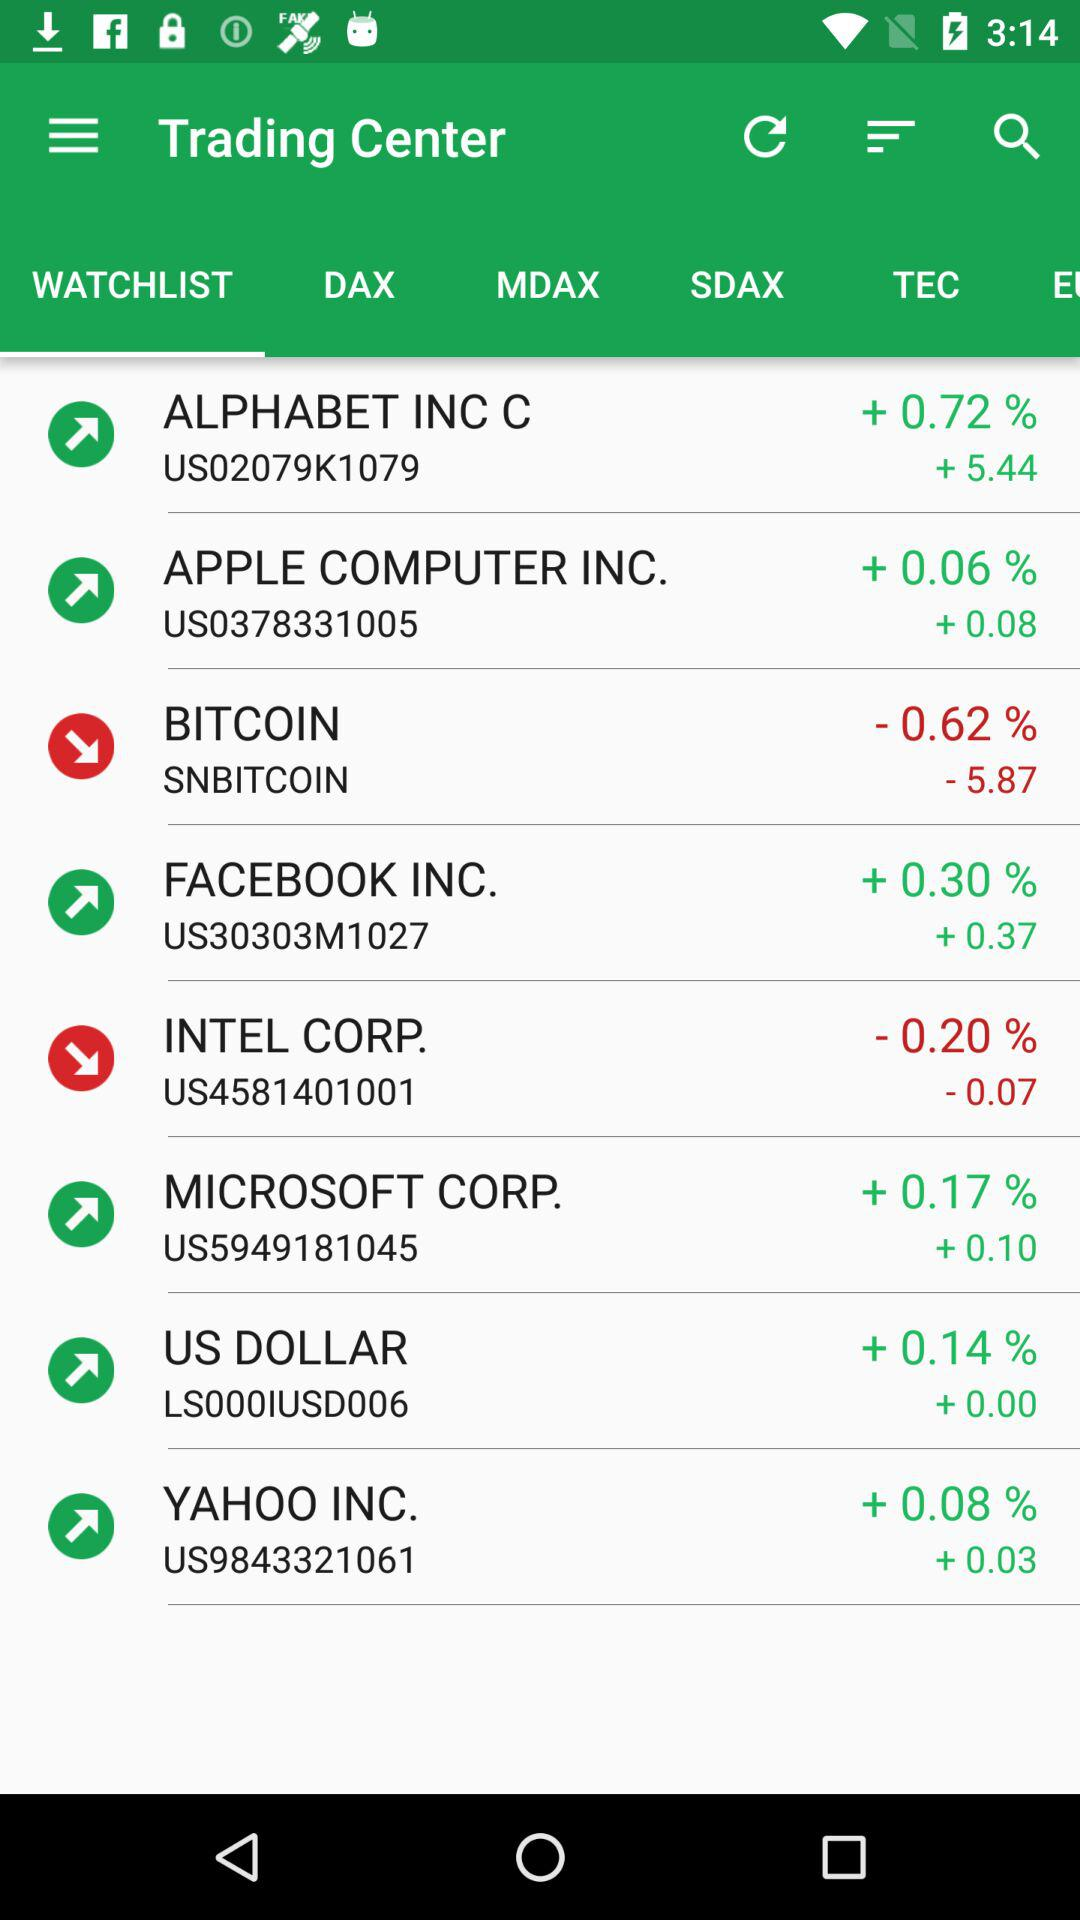Which stock has a higher percentage change, Bitcoin or Intel Corp.?
Answer the question using a single word or phrase. Bitcoin 